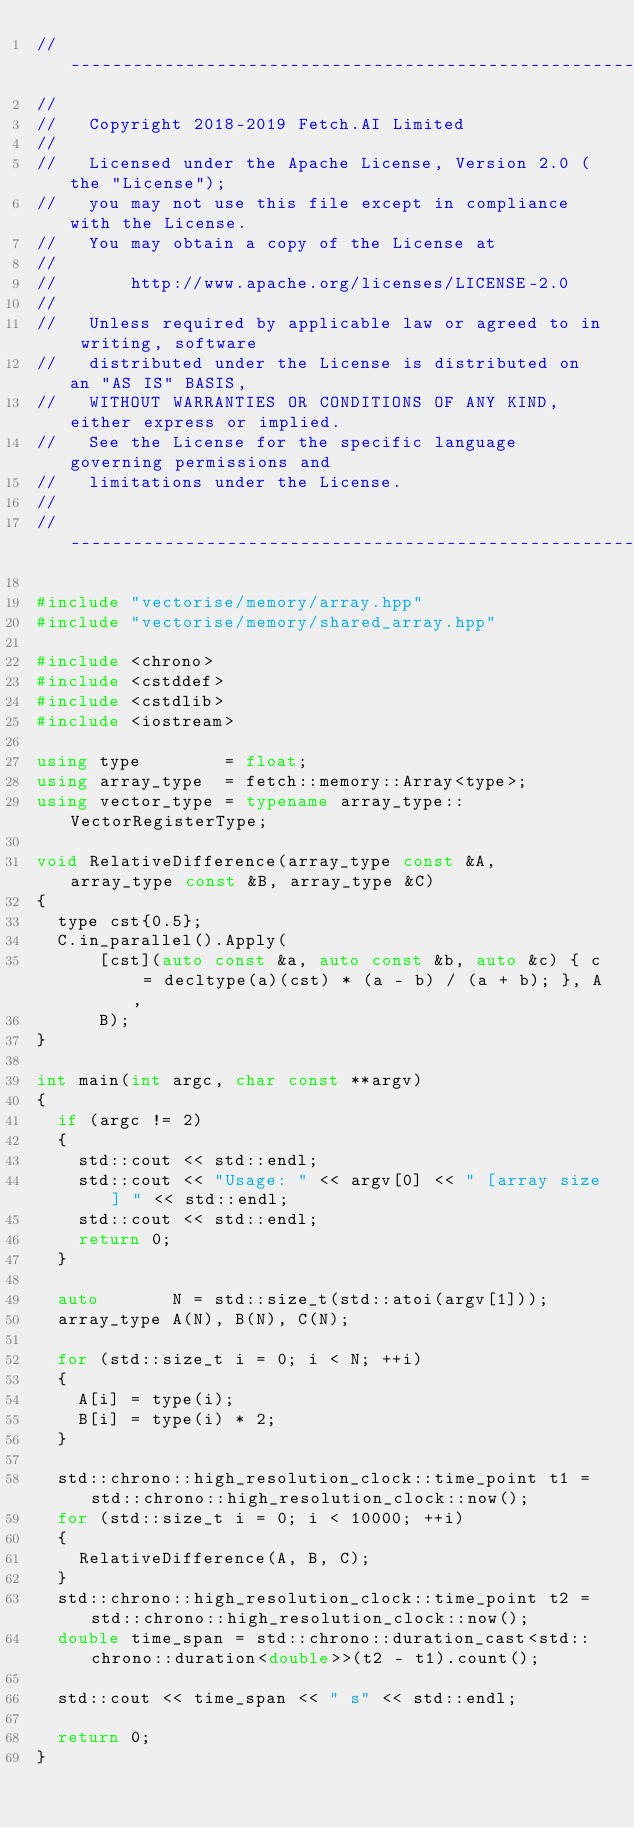Convert code to text. <code><loc_0><loc_0><loc_500><loc_500><_C++_>//------------------------------------------------------------------------------
//
//   Copyright 2018-2019 Fetch.AI Limited
//
//   Licensed under the Apache License, Version 2.0 (the "License");
//   you may not use this file except in compliance with the License.
//   You may obtain a copy of the License at
//
//       http://www.apache.org/licenses/LICENSE-2.0
//
//   Unless required by applicable law or agreed to in writing, software
//   distributed under the License is distributed on an "AS IS" BASIS,
//   WITHOUT WARRANTIES OR CONDITIONS OF ANY KIND, either express or implied.
//   See the License for the specific language governing permissions and
//   limitations under the License.
//
//------------------------------------------------------------------------------

#include "vectorise/memory/array.hpp"
#include "vectorise/memory/shared_array.hpp"

#include <chrono>
#include <cstddef>
#include <cstdlib>
#include <iostream>

using type        = float;
using array_type  = fetch::memory::Array<type>;
using vector_type = typename array_type::VectorRegisterType;

void RelativeDifference(array_type const &A, array_type const &B, array_type &C)
{
  type cst{0.5};
  C.in_parallel().Apply(
      [cst](auto const &a, auto const &b, auto &c) { c = decltype(a)(cst) * (a - b) / (a + b); }, A,
      B);
}

int main(int argc, char const **argv)
{
  if (argc != 2)
  {
    std::cout << std::endl;
    std::cout << "Usage: " << argv[0] << " [array size] " << std::endl;
    std::cout << std::endl;
    return 0;
  }

  auto       N = std::size_t(std::atoi(argv[1]));
  array_type A(N), B(N), C(N);

  for (std::size_t i = 0; i < N; ++i)
  {
    A[i] = type(i);
    B[i] = type(i) * 2;
  }

  std::chrono::high_resolution_clock::time_point t1 = std::chrono::high_resolution_clock::now();
  for (std::size_t i = 0; i < 10000; ++i)
  {
    RelativeDifference(A, B, C);
  }
  std::chrono::high_resolution_clock::time_point t2 = std::chrono::high_resolution_clock::now();
  double time_span = std::chrono::duration_cast<std::chrono::duration<double>>(t2 - t1).count();

  std::cout << time_span << " s" << std::endl;

  return 0;
}
</code> 